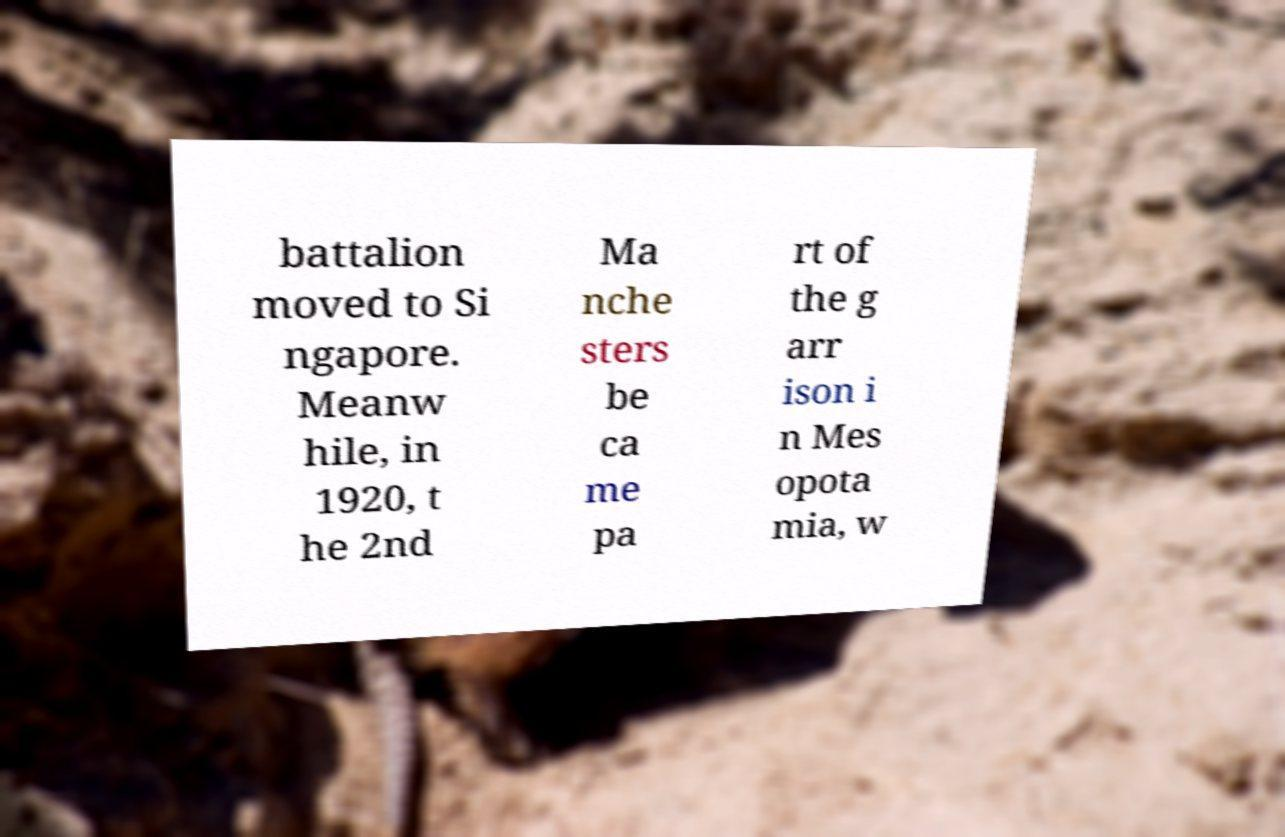I need the written content from this picture converted into text. Can you do that? battalion moved to Si ngapore. Meanw hile, in 1920, t he 2nd Ma nche sters be ca me pa rt of the g arr ison i n Mes opota mia, w 